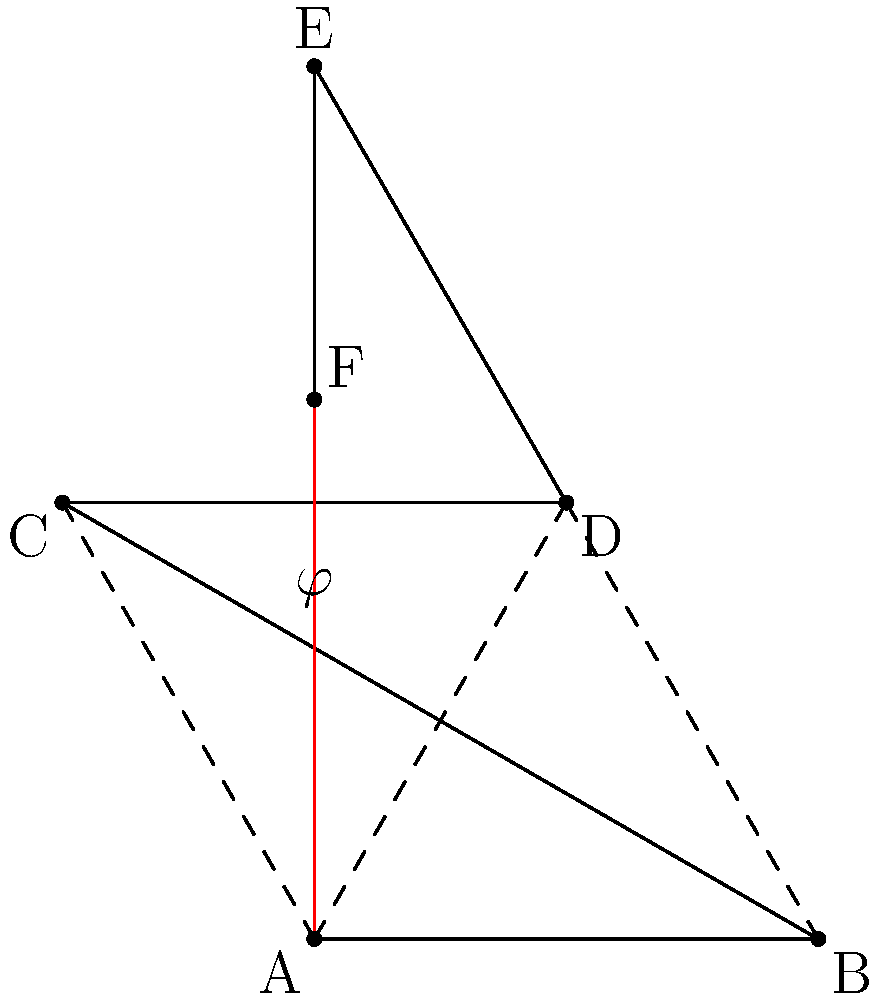In the construction of a pentagram, the golden ratio ($\varphi$) plays a crucial role. Consider the pentagram ABCDE with point F on line AE. If AF:FE = $\varphi$:1, what is the value of $\varphi$ to three decimal places? How does this ratio relate to the concept of divine proportion often discussed in alternative design theories? To find the value of $\varphi$ (phi), we need to understand its definition and properties:

1) The golden ratio is defined as a number where the ratio of the whole to the larger part is equal to the ratio of the larger part to the smaller part.

2) Mathematically, this can be expressed as:
   $\frac{a+b}{a} = \frac{a}{b} = \varphi$

3) From this, we can derive the quadratic equation:
   $\varphi^2 = \varphi + 1$

4) Solving this equation:
   $\varphi^2 - \varphi - 1 = 0$
   $\varphi = \frac{1 + \sqrt{5}}{2}$

5) Calculating this value:
   $\varphi = \frac{1 + \sqrt{5}}{2} \approx 1.618033988749895$

6) Rounding to three decimal places:
   $\varphi \approx 1.618$

The golden ratio is often referred to as the "divine proportion" in alternative design theories because of its perceived aesthetic appeal and its occurrence in nature. In the pentagram, it appears in several ways:

- The ratio of the length of the longer segment to the shorter segment in any of the lines intersecting within the pentagram is $\varphi$.
- The ratio of the length of a pentagram's side to the length of its inner segment is also $\varphi$.

This ubiquity in the pentagram, combined with its presence in art, architecture, and nature, has led some to attribute mystical or divine properties to this ratio, challenging mainstream scientific narratives about its significance.
Answer: $\varphi \approx 1.618$ 